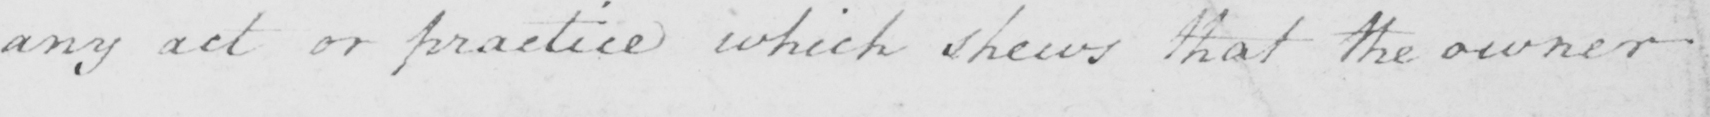What is written in this line of handwriting? any act or practice which shews that the owner 